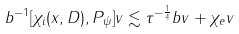Convert formula to latex. <formula><loc_0><loc_0><loc_500><loc_500>\| b ^ { - 1 } [ \chi _ { i } ( x , D ) , P _ { \psi } ] v \| \lesssim \tau ^ { - \frac { 1 } { 4 } } \| b v \| + \| \chi _ { e } v \|</formula> 